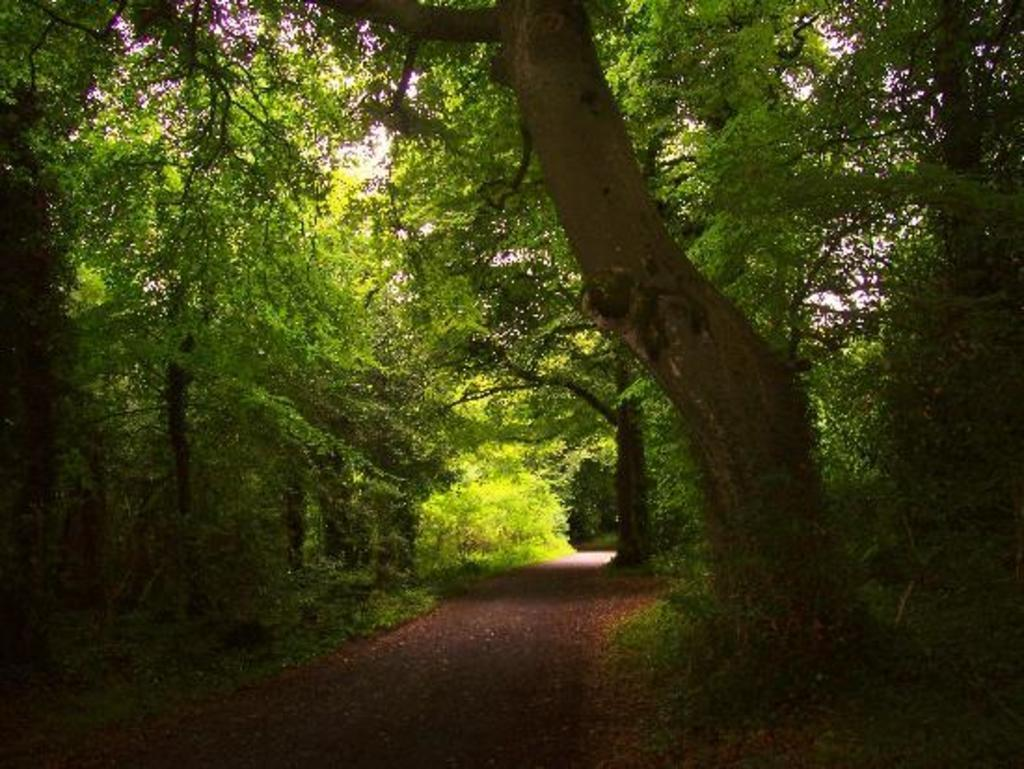What is the main feature in the center of the image? There is a road in the center of the image. What can be seen in the background or along the sides of the road? Trees are visible in the image. What type of class is being taught in the image? There is no class or teaching activity present in the image; it features a road and trees. How many fire hydrants can be seen along the road in the image? There are no fire hydrants visible in the image; it only shows a road and trees. 